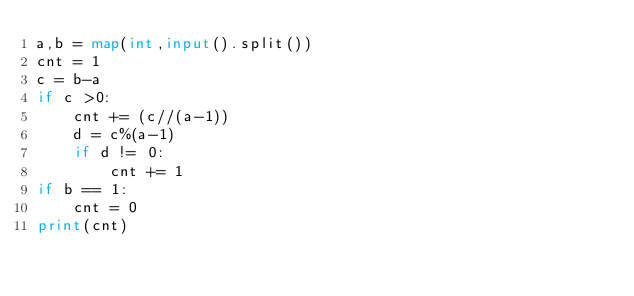Convert code to text. <code><loc_0><loc_0><loc_500><loc_500><_Python_>a,b = map(int,input().split())
cnt = 1
c = b-a
if c >0:
    cnt += (c//(a-1))
    d = c%(a-1)
    if d != 0:
        cnt += 1
if b == 1:
    cnt = 0
print(cnt)</code> 